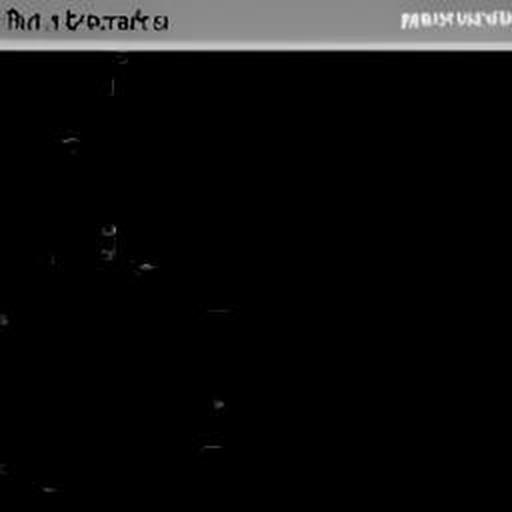What could this image be of, assuming the darkness is intentional? If the darkness is intentional, the image might capture a low-light environment, such as a night scene, an artistic expression of darkness, or perhaps an object with very little illumination. Without further context or visible details, it's speculative to suggest specific content. 